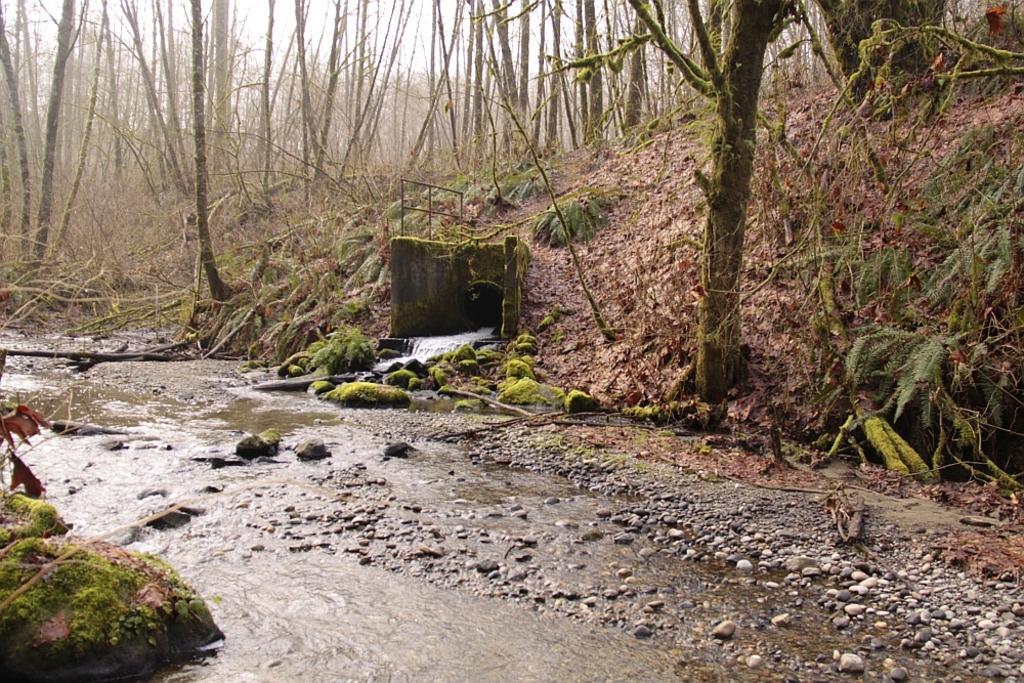Can you describe this image briefly? In this there are trees, there is water flowing, there are stones,there are grass. 